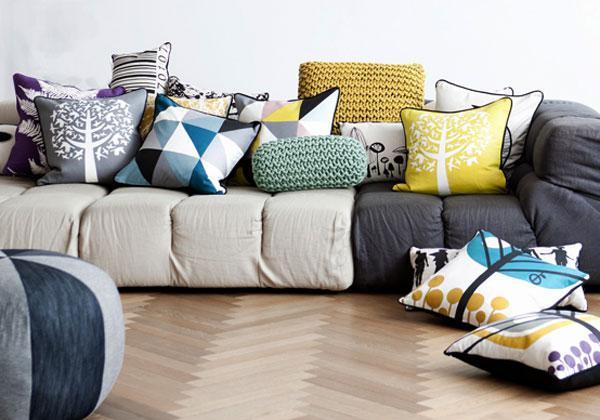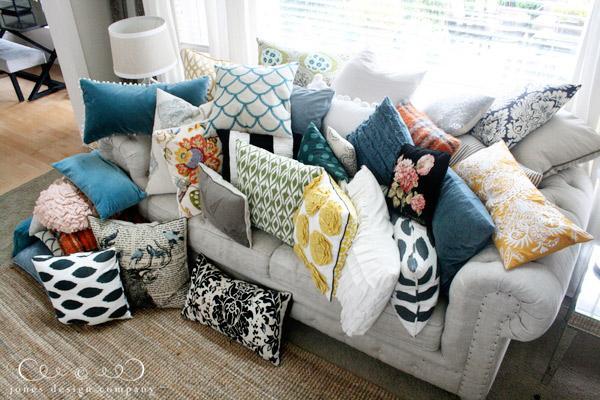The first image is the image on the left, the second image is the image on the right. Examine the images to the left and right. Is the description "There is a couch with rolled arms and at least one of its pillows has a bold, geometric black and white design." accurate? Answer yes or no. Yes. The first image is the image on the left, the second image is the image on the right. Analyze the images presented: Is the assertion "There is a blue couch on the right image" valid? Answer yes or no. No. 